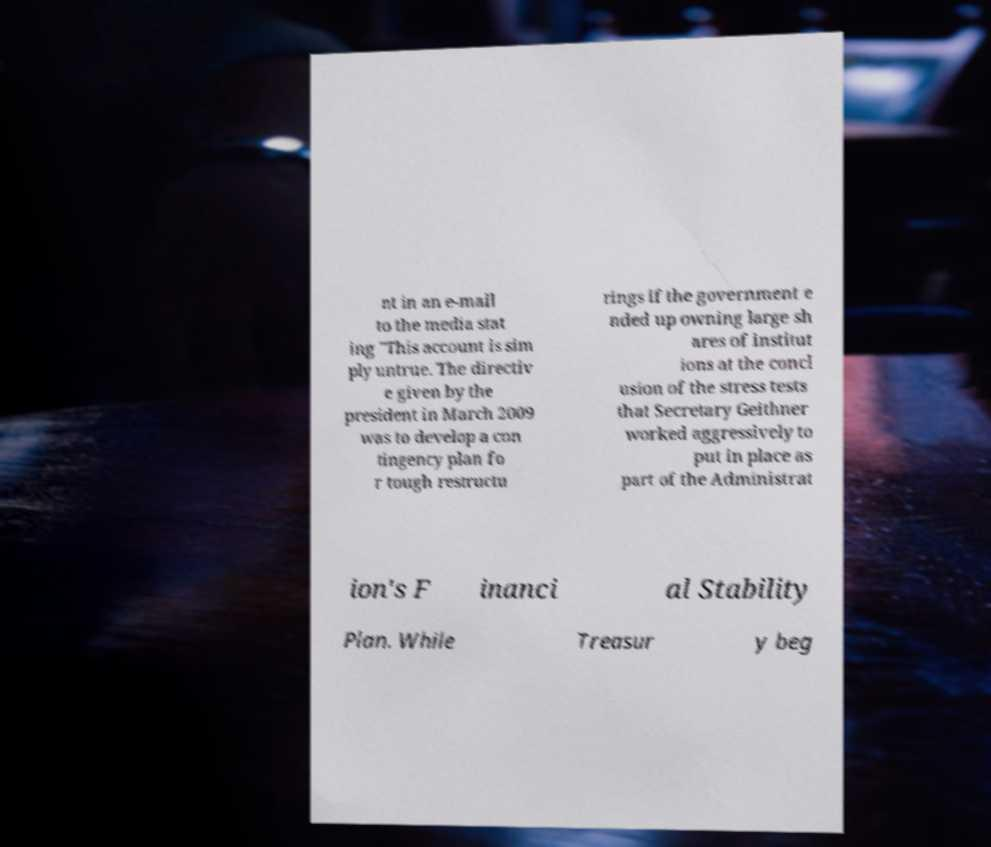Can you accurately transcribe the text from the provided image for me? nt in an e-mail to the media stat ing "This account is sim ply untrue. The directiv e given by the president in March 2009 was to develop a con tingency plan fo r tough restructu rings if the government e nded up owning large sh ares of institut ions at the concl usion of the stress tests that Secretary Geithner worked aggressively to put in place as part of the Administrat ion's F inanci al Stability Plan. While Treasur y beg 